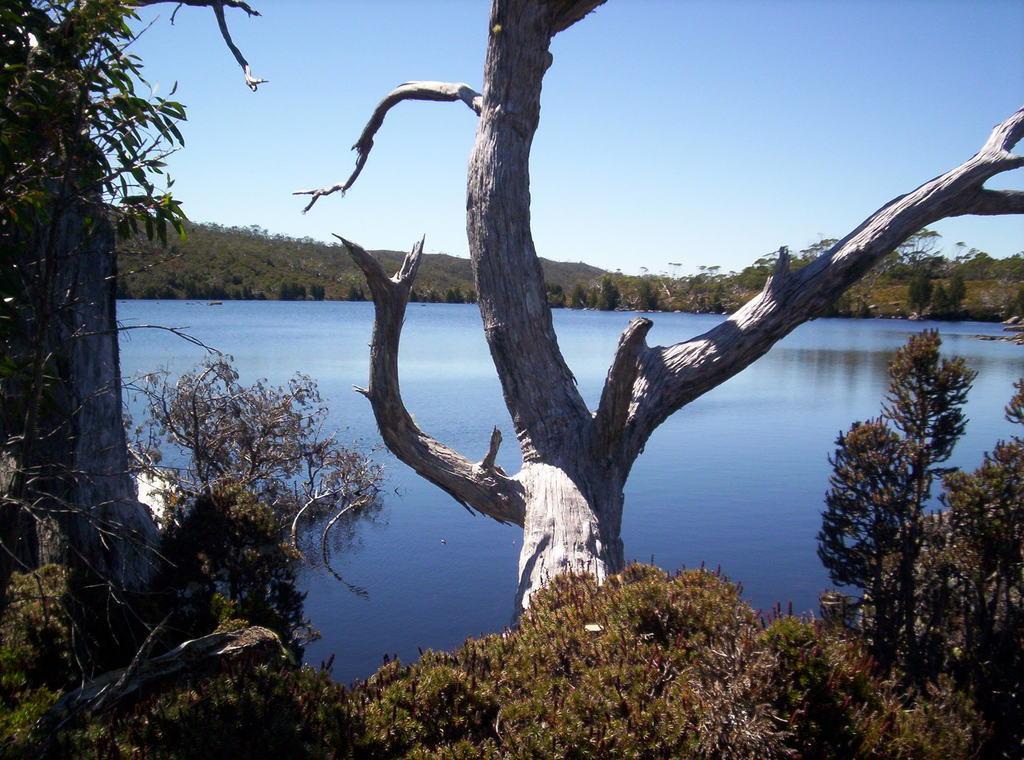Please provide a concise description of this image. In this image, we can see some trees. There is a lake and stem in the middle of the image. There is a sky at the top of the image. 